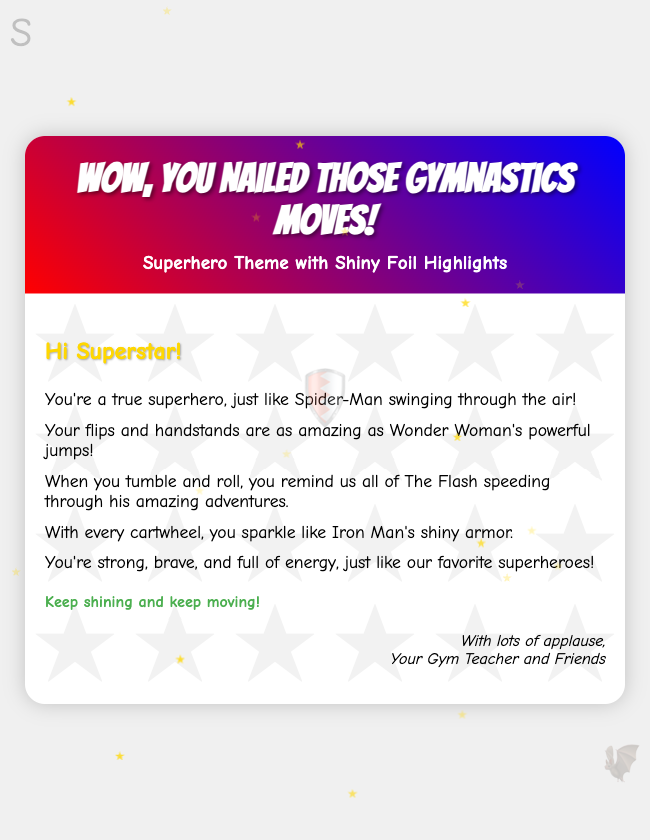What is the title of the card? The title of the card is displayed prominently in the header section of the document.
Answer: Wow, You Nailed Those Gymnastics Moves! Who is the recipient addressed as? The greeting at the top of the card addresses the recipient by a specific title.
Answer: Superstar Which superhero is mentioned for swinging through the air? The text describes one of the superheroes who symbolizes agility.
Answer: Spider-Man What is compared to Wonder Woman's powerful jumps? The message mentions another gymnastics skill that aligns with superhero abilities.
Answer: Flips and handstands How many superhero elements are present in the document? The visual elements are counted based on how many superhero symbols are included.
Answer: Three What colors are used in the card header's gradient? The gradient background of the header uses two specific colors.
Answer: Red and blue What is the closing phrase of the card? The closing remarks sum up the encouragement given to the recipient.
Answer: Keep shining and keep moving! Who signed off the card? The sign-off identifies the author(s) of the message.
Answer: Your Gym Teacher and Friends 